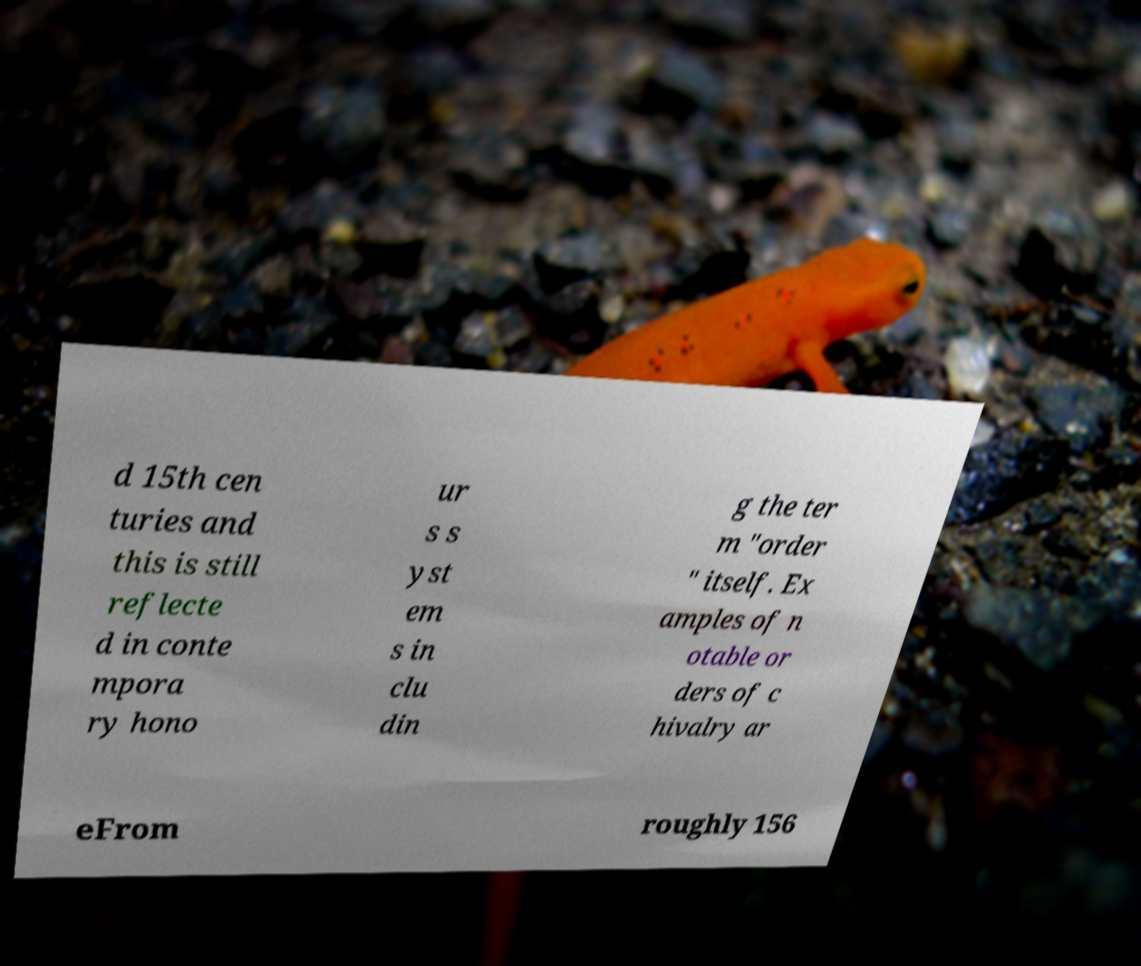There's text embedded in this image that I need extracted. Can you transcribe it verbatim? d 15th cen turies and this is still reflecte d in conte mpora ry hono ur s s yst em s in clu din g the ter m "order " itself. Ex amples of n otable or ders of c hivalry ar eFrom roughly 156 